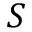<formula> <loc_0><loc_0><loc_500><loc_500>S</formula> 